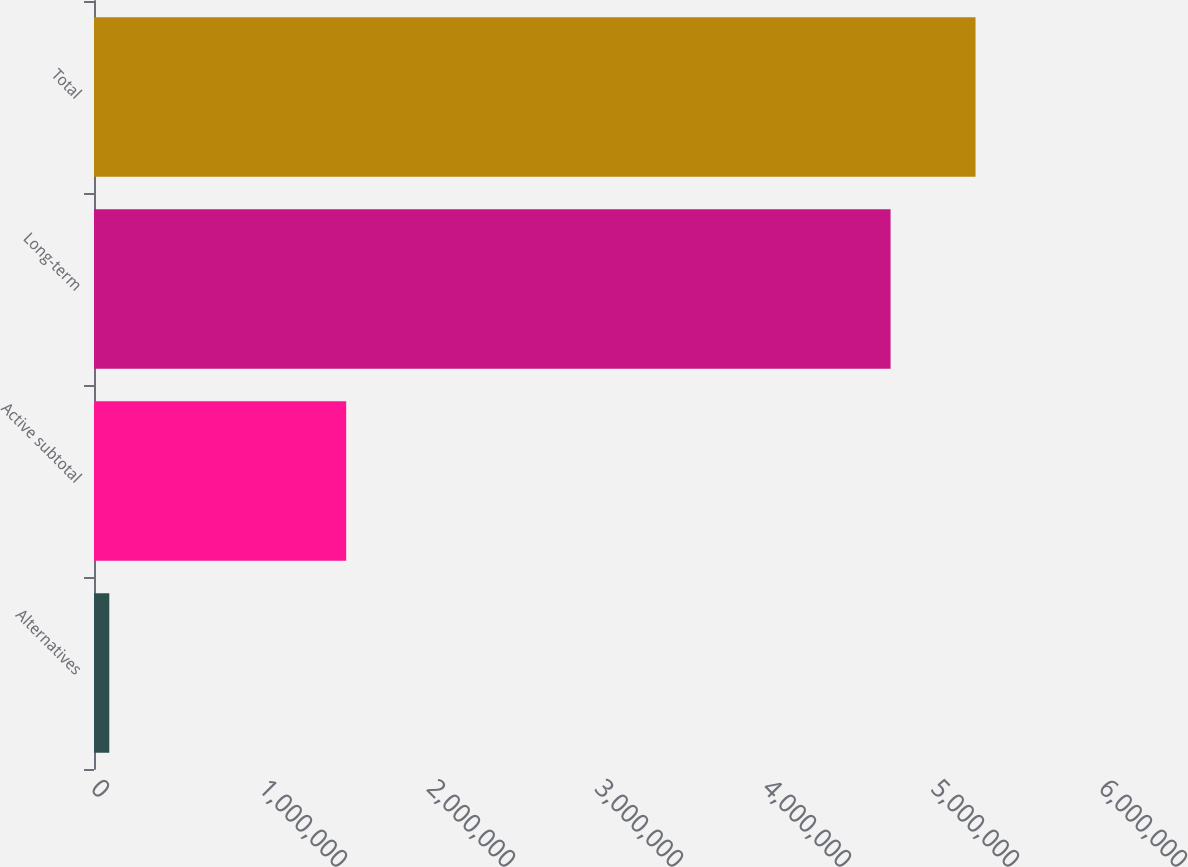<chart> <loc_0><loc_0><loc_500><loc_500><bar_chart><fcel>Alternatives<fcel>Active subtotal<fcel>Long-term<fcel>Total<nl><fcel>91093<fcel>1.50105e+06<fcel>4.74149e+06<fcel>5.24716e+06<nl></chart> 